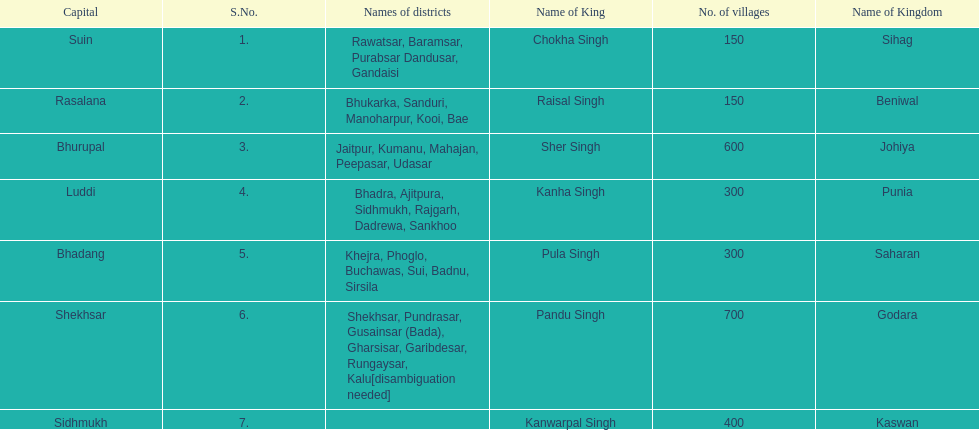How many districts does punia have? 6. 